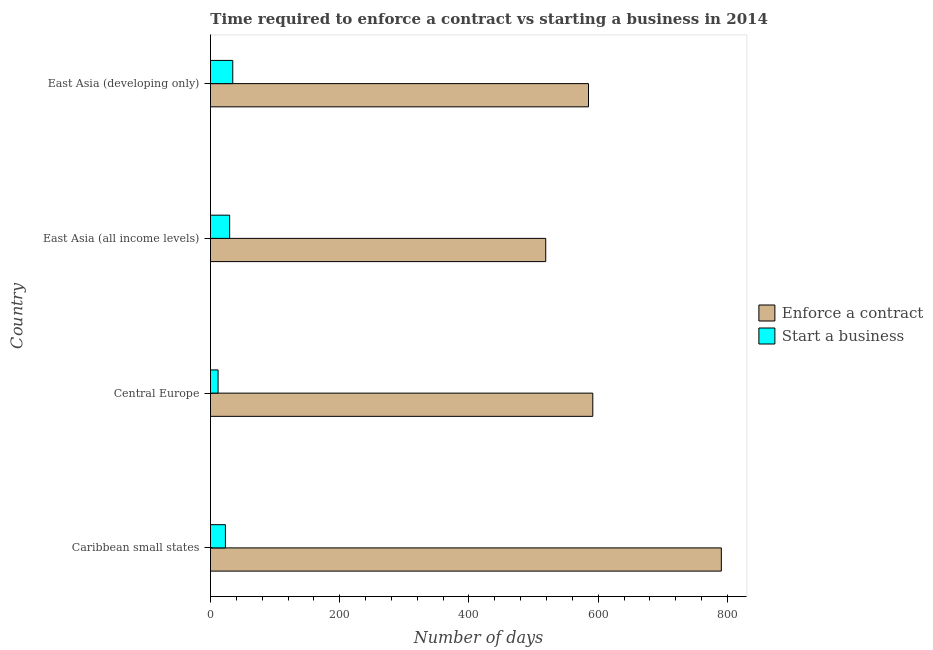Are the number of bars on each tick of the Y-axis equal?
Your answer should be very brief. Yes. How many bars are there on the 4th tick from the top?
Provide a short and direct response. 2. How many bars are there on the 3rd tick from the bottom?
Ensure brevity in your answer.  2. What is the label of the 2nd group of bars from the top?
Make the answer very short. East Asia (all income levels). What is the number of days to enforece a contract in East Asia (all income levels)?
Provide a succinct answer. 518.82. Across all countries, what is the maximum number of days to start a business?
Your answer should be very brief. 34.5. Across all countries, what is the minimum number of days to enforece a contract?
Provide a succinct answer. 518.82. In which country was the number of days to start a business maximum?
Make the answer very short. East Asia (developing only). In which country was the number of days to start a business minimum?
Give a very brief answer. Central Europe. What is the total number of days to start a business in the graph?
Your answer should be compact. 99.06. What is the difference between the number of days to enforece a contract in Caribbean small states and that in East Asia (all income levels)?
Your answer should be very brief. 271.72. What is the difference between the number of days to start a business in Caribbean small states and the number of days to enforece a contract in East Asia (all income levels)?
Your answer should be very brief. -495.71. What is the average number of days to start a business per country?
Your answer should be very brief. 24.77. What is the difference between the number of days to enforece a contract and number of days to start a business in Central Europe?
Make the answer very short. 579.86. In how many countries, is the number of days to start a business greater than 160 days?
Your answer should be very brief. 0. Is the number of days to enforece a contract in Caribbean small states less than that in Central Europe?
Keep it short and to the point. No. What is the difference between the highest and the second highest number of days to start a business?
Ensure brevity in your answer.  4.82. What is the difference between the highest and the lowest number of days to start a business?
Give a very brief answer. 22.72. In how many countries, is the number of days to enforece a contract greater than the average number of days to enforece a contract taken over all countries?
Your answer should be very brief. 1. What does the 2nd bar from the top in Central Europe represents?
Your answer should be very brief. Enforce a contract. What does the 1st bar from the bottom in Caribbean small states represents?
Offer a very short reply. Enforce a contract. Does the graph contain any zero values?
Keep it short and to the point. No. Does the graph contain grids?
Offer a very short reply. No. Where does the legend appear in the graph?
Offer a terse response. Center right. How many legend labels are there?
Ensure brevity in your answer.  2. What is the title of the graph?
Make the answer very short. Time required to enforce a contract vs starting a business in 2014. What is the label or title of the X-axis?
Ensure brevity in your answer.  Number of days. What is the label or title of the Y-axis?
Give a very brief answer. Country. What is the Number of days of Enforce a contract in Caribbean small states?
Offer a terse response. 790.54. What is the Number of days of Start a business in Caribbean small states?
Offer a very short reply. 23.12. What is the Number of days of Enforce a contract in Central Europe?
Offer a very short reply. 591.64. What is the Number of days of Start a business in Central Europe?
Keep it short and to the point. 11.77. What is the Number of days in Enforce a contract in East Asia (all income levels)?
Offer a very short reply. 518.82. What is the Number of days of Start a business in East Asia (all income levels)?
Offer a very short reply. 29.68. What is the Number of days in Enforce a contract in East Asia (developing only)?
Your response must be concise. 584.99. What is the Number of days in Start a business in East Asia (developing only)?
Ensure brevity in your answer.  34.5. Across all countries, what is the maximum Number of days in Enforce a contract?
Keep it short and to the point. 790.54. Across all countries, what is the maximum Number of days in Start a business?
Provide a succinct answer. 34.5. Across all countries, what is the minimum Number of days of Enforce a contract?
Keep it short and to the point. 518.82. Across all countries, what is the minimum Number of days in Start a business?
Make the answer very short. 11.77. What is the total Number of days in Enforce a contract in the graph?
Make the answer very short. 2485.99. What is the total Number of days in Start a business in the graph?
Keep it short and to the point. 99.06. What is the difference between the Number of days of Enforce a contract in Caribbean small states and that in Central Europe?
Keep it short and to the point. 198.9. What is the difference between the Number of days in Start a business in Caribbean small states and that in Central Europe?
Your answer should be compact. 11.34. What is the difference between the Number of days in Enforce a contract in Caribbean small states and that in East Asia (all income levels)?
Ensure brevity in your answer.  271.72. What is the difference between the Number of days in Start a business in Caribbean small states and that in East Asia (all income levels)?
Your answer should be very brief. -6.56. What is the difference between the Number of days of Enforce a contract in Caribbean small states and that in East Asia (developing only)?
Provide a short and direct response. 205.55. What is the difference between the Number of days of Start a business in Caribbean small states and that in East Asia (developing only)?
Keep it short and to the point. -11.38. What is the difference between the Number of days in Enforce a contract in Central Europe and that in East Asia (all income levels)?
Keep it short and to the point. 72.82. What is the difference between the Number of days in Start a business in Central Europe and that in East Asia (all income levels)?
Provide a succinct answer. -17.9. What is the difference between the Number of days of Enforce a contract in Central Europe and that in East Asia (developing only)?
Make the answer very short. 6.65. What is the difference between the Number of days of Start a business in Central Europe and that in East Asia (developing only)?
Make the answer very short. -22.72. What is the difference between the Number of days of Enforce a contract in East Asia (all income levels) and that in East Asia (developing only)?
Provide a short and direct response. -66.17. What is the difference between the Number of days of Start a business in East Asia (all income levels) and that in East Asia (developing only)?
Give a very brief answer. -4.82. What is the difference between the Number of days of Enforce a contract in Caribbean small states and the Number of days of Start a business in Central Europe?
Provide a succinct answer. 778.77. What is the difference between the Number of days of Enforce a contract in Caribbean small states and the Number of days of Start a business in East Asia (all income levels)?
Ensure brevity in your answer.  760.86. What is the difference between the Number of days in Enforce a contract in Caribbean small states and the Number of days in Start a business in East Asia (developing only)?
Ensure brevity in your answer.  756.04. What is the difference between the Number of days in Enforce a contract in Central Europe and the Number of days in Start a business in East Asia (all income levels)?
Your response must be concise. 561.96. What is the difference between the Number of days in Enforce a contract in Central Europe and the Number of days in Start a business in East Asia (developing only)?
Give a very brief answer. 557.14. What is the difference between the Number of days of Enforce a contract in East Asia (all income levels) and the Number of days of Start a business in East Asia (developing only)?
Your answer should be very brief. 484.33. What is the average Number of days in Enforce a contract per country?
Make the answer very short. 621.5. What is the average Number of days of Start a business per country?
Offer a very short reply. 24.76. What is the difference between the Number of days in Enforce a contract and Number of days in Start a business in Caribbean small states?
Your response must be concise. 767.42. What is the difference between the Number of days in Enforce a contract and Number of days in Start a business in Central Europe?
Give a very brief answer. 579.86. What is the difference between the Number of days of Enforce a contract and Number of days of Start a business in East Asia (all income levels)?
Provide a succinct answer. 489.14. What is the difference between the Number of days in Enforce a contract and Number of days in Start a business in East Asia (developing only)?
Provide a succinct answer. 550.5. What is the ratio of the Number of days of Enforce a contract in Caribbean small states to that in Central Europe?
Provide a succinct answer. 1.34. What is the ratio of the Number of days in Start a business in Caribbean small states to that in Central Europe?
Give a very brief answer. 1.96. What is the ratio of the Number of days in Enforce a contract in Caribbean small states to that in East Asia (all income levels)?
Provide a short and direct response. 1.52. What is the ratio of the Number of days of Start a business in Caribbean small states to that in East Asia (all income levels)?
Make the answer very short. 0.78. What is the ratio of the Number of days of Enforce a contract in Caribbean small states to that in East Asia (developing only)?
Provide a short and direct response. 1.35. What is the ratio of the Number of days in Start a business in Caribbean small states to that in East Asia (developing only)?
Keep it short and to the point. 0.67. What is the ratio of the Number of days of Enforce a contract in Central Europe to that in East Asia (all income levels)?
Your answer should be very brief. 1.14. What is the ratio of the Number of days of Start a business in Central Europe to that in East Asia (all income levels)?
Keep it short and to the point. 0.4. What is the ratio of the Number of days of Enforce a contract in Central Europe to that in East Asia (developing only)?
Ensure brevity in your answer.  1.01. What is the ratio of the Number of days in Start a business in Central Europe to that in East Asia (developing only)?
Your response must be concise. 0.34. What is the ratio of the Number of days in Enforce a contract in East Asia (all income levels) to that in East Asia (developing only)?
Provide a succinct answer. 0.89. What is the ratio of the Number of days of Start a business in East Asia (all income levels) to that in East Asia (developing only)?
Offer a very short reply. 0.86. What is the difference between the highest and the second highest Number of days of Enforce a contract?
Offer a terse response. 198.9. What is the difference between the highest and the second highest Number of days in Start a business?
Offer a very short reply. 4.82. What is the difference between the highest and the lowest Number of days of Enforce a contract?
Ensure brevity in your answer.  271.72. What is the difference between the highest and the lowest Number of days in Start a business?
Make the answer very short. 22.72. 